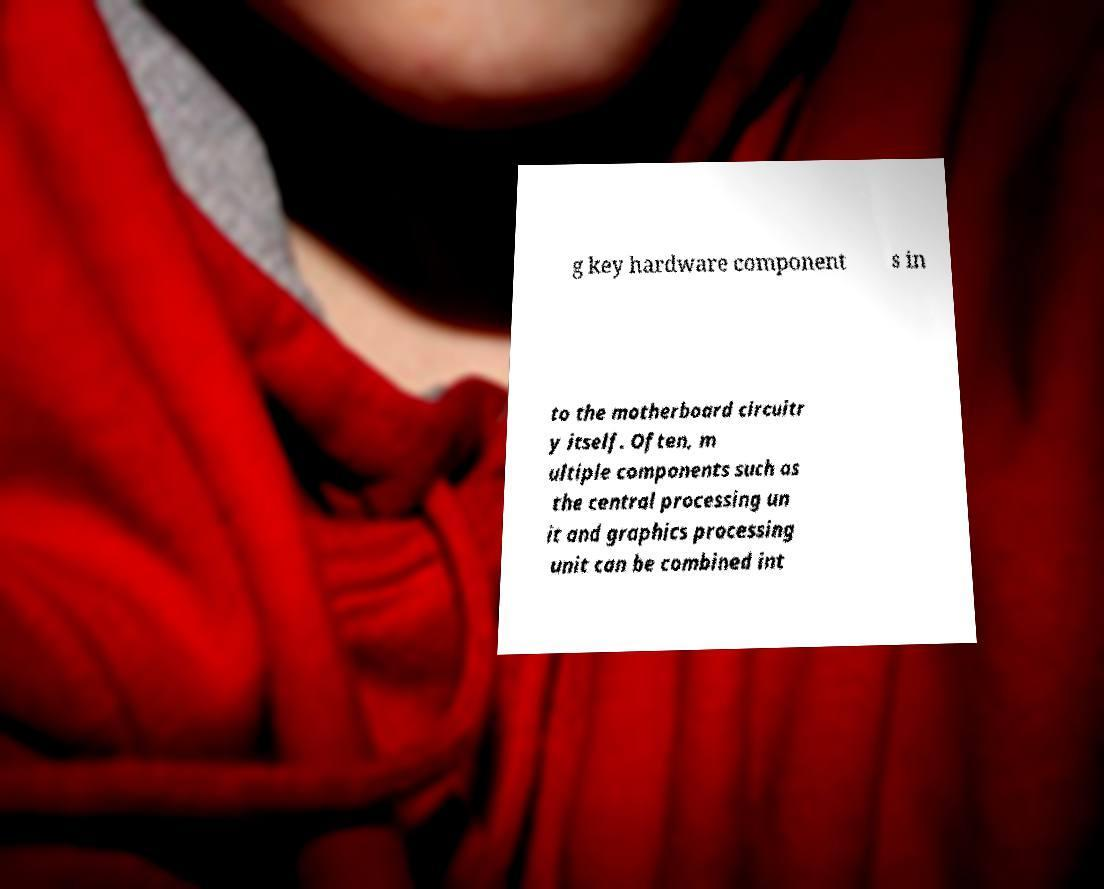Please identify and transcribe the text found in this image. g key hardware component s in to the motherboard circuitr y itself. Often, m ultiple components such as the central processing un it and graphics processing unit can be combined int 